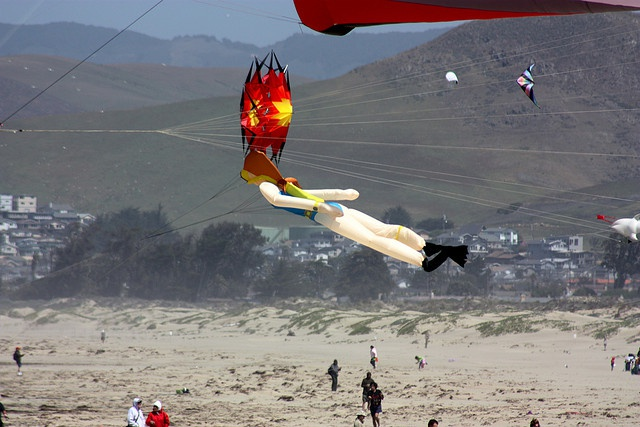Describe the objects in this image and their specific colors. I can see kite in gray, ivory, tan, black, and maroon tones, kite in gray, maroon, black, and darkgray tones, kite in gray, maroon, red, and black tones, people in gray, black, darkgray, and maroon tones, and kite in gray, lightgray, and darkgray tones in this image. 